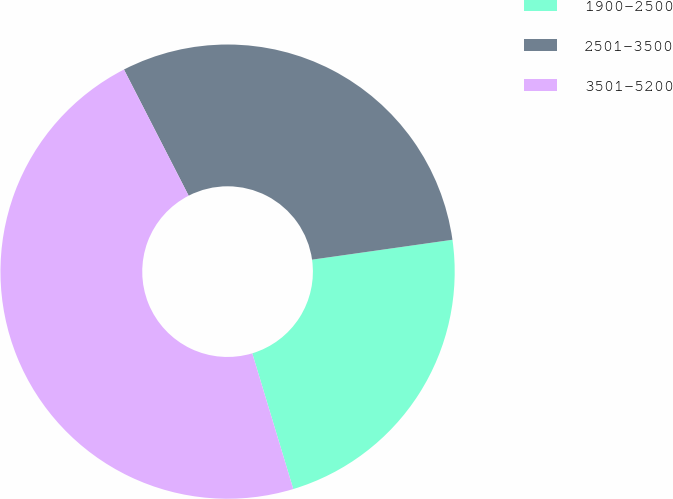Convert chart to OTSL. <chart><loc_0><loc_0><loc_500><loc_500><pie_chart><fcel>1900-2500<fcel>2501-3500<fcel>3501-5200<nl><fcel>22.57%<fcel>30.3%<fcel>47.13%<nl></chart> 